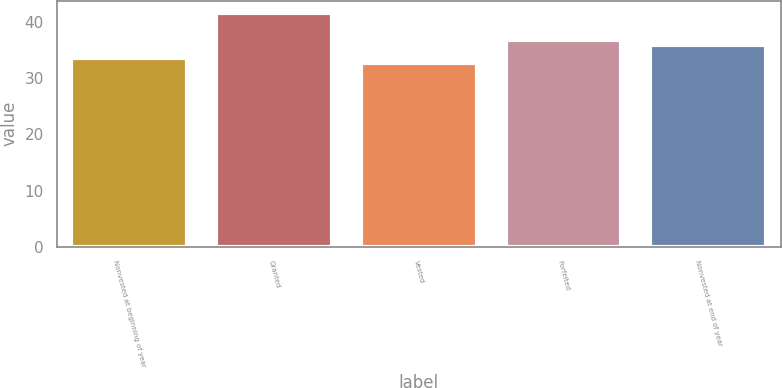Convert chart to OTSL. <chart><loc_0><loc_0><loc_500><loc_500><bar_chart><fcel>Nonvested at beginning of year<fcel>Granted<fcel>Vested<fcel>Forfeited<fcel>Nonvested at end of year<nl><fcel>33.67<fcel>41.73<fcel>32.78<fcel>36.83<fcel>35.94<nl></chart> 